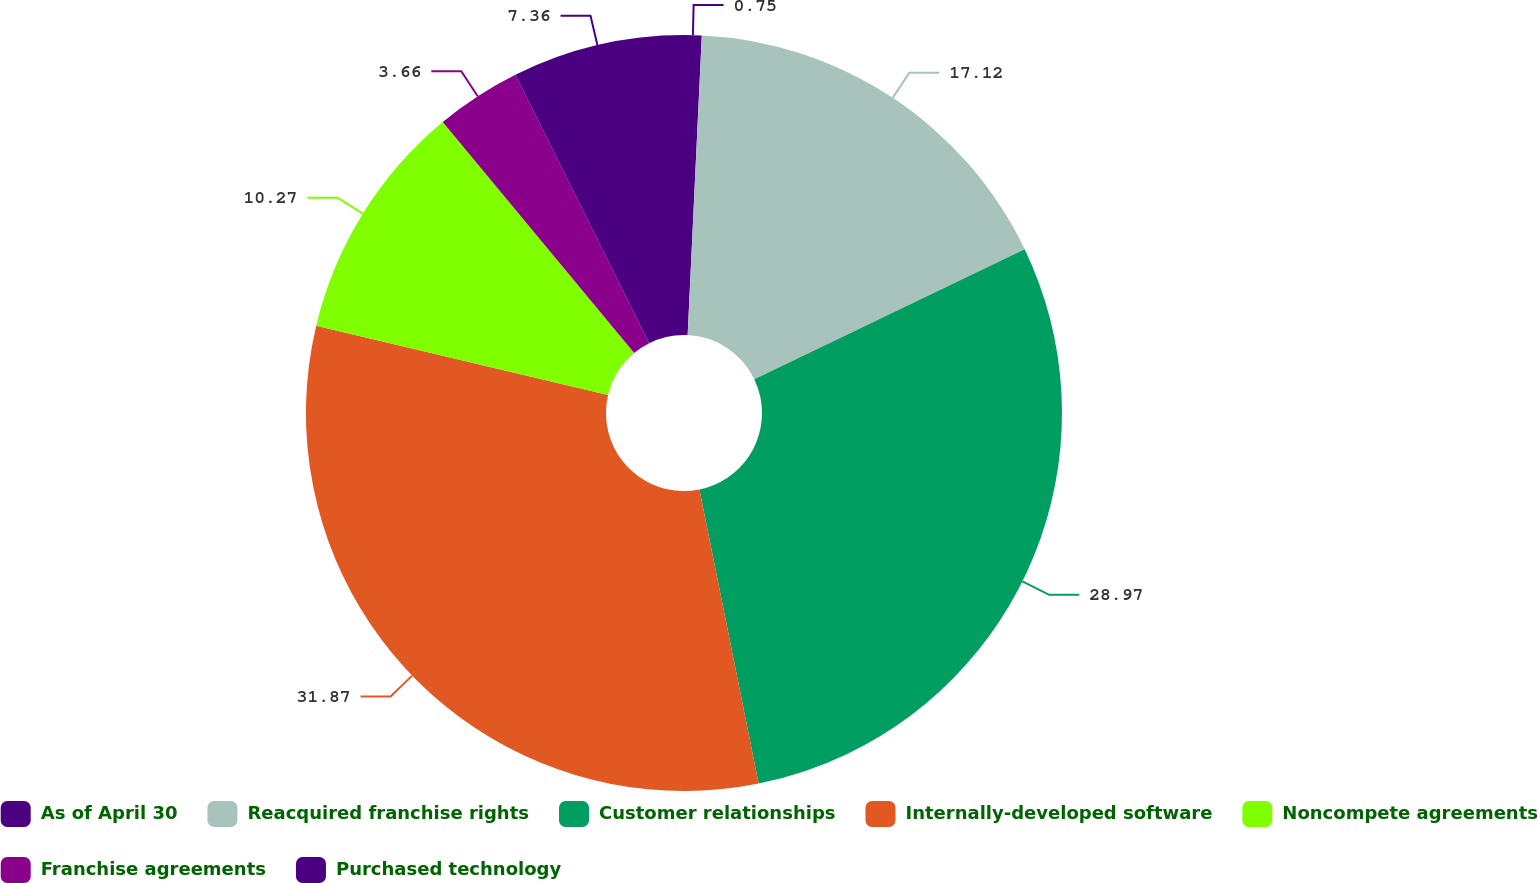Convert chart to OTSL. <chart><loc_0><loc_0><loc_500><loc_500><pie_chart><fcel>As of April 30<fcel>Reacquired franchise rights<fcel>Customer relationships<fcel>Internally-developed software<fcel>Noncompete agreements<fcel>Franchise agreements<fcel>Purchased technology<nl><fcel>0.75%<fcel>17.12%<fcel>28.97%<fcel>31.88%<fcel>10.27%<fcel>3.66%<fcel>7.36%<nl></chart> 